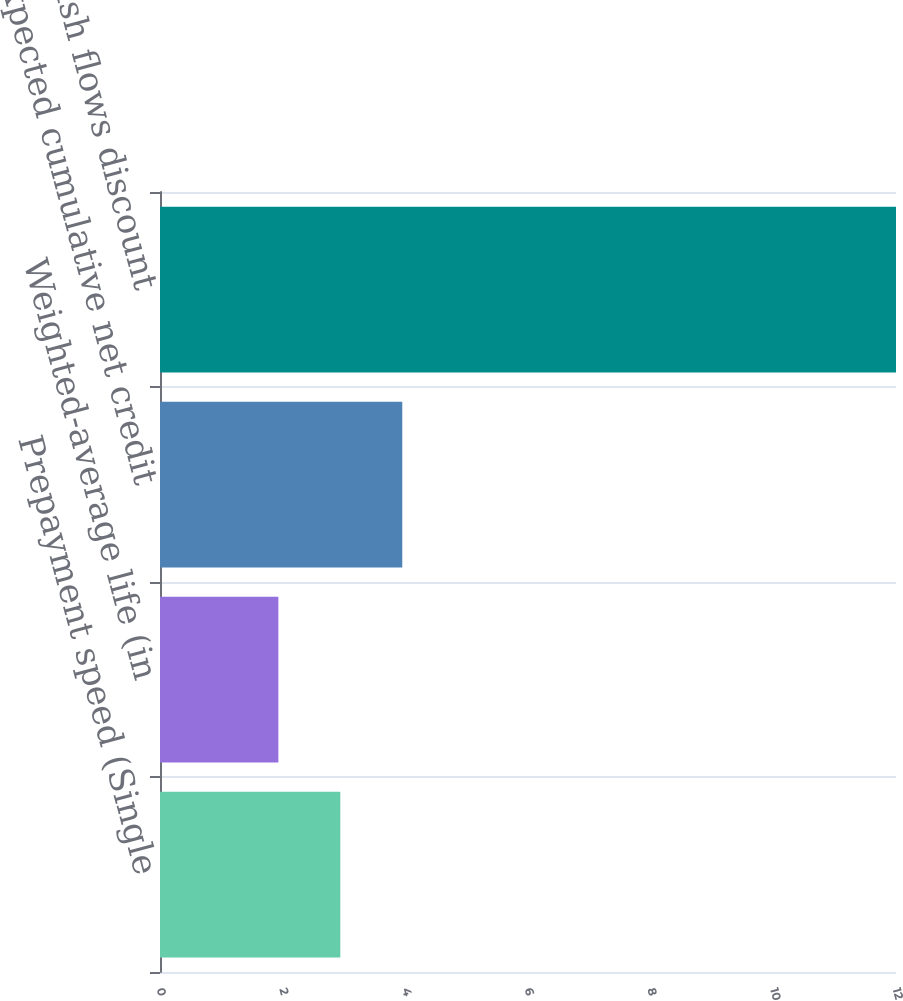Convert chart to OTSL. <chart><loc_0><loc_0><loc_500><loc_500><bar_chart><fcel>Prepayment speed (Single<fcel>Weighted-average life (in<fcel>Expected cumulative net credit<fcel>Residual cash flows discount<nl><fcel>2.94<fcel>1.93<fcel>3.95<fcel>12<nl></chart> 